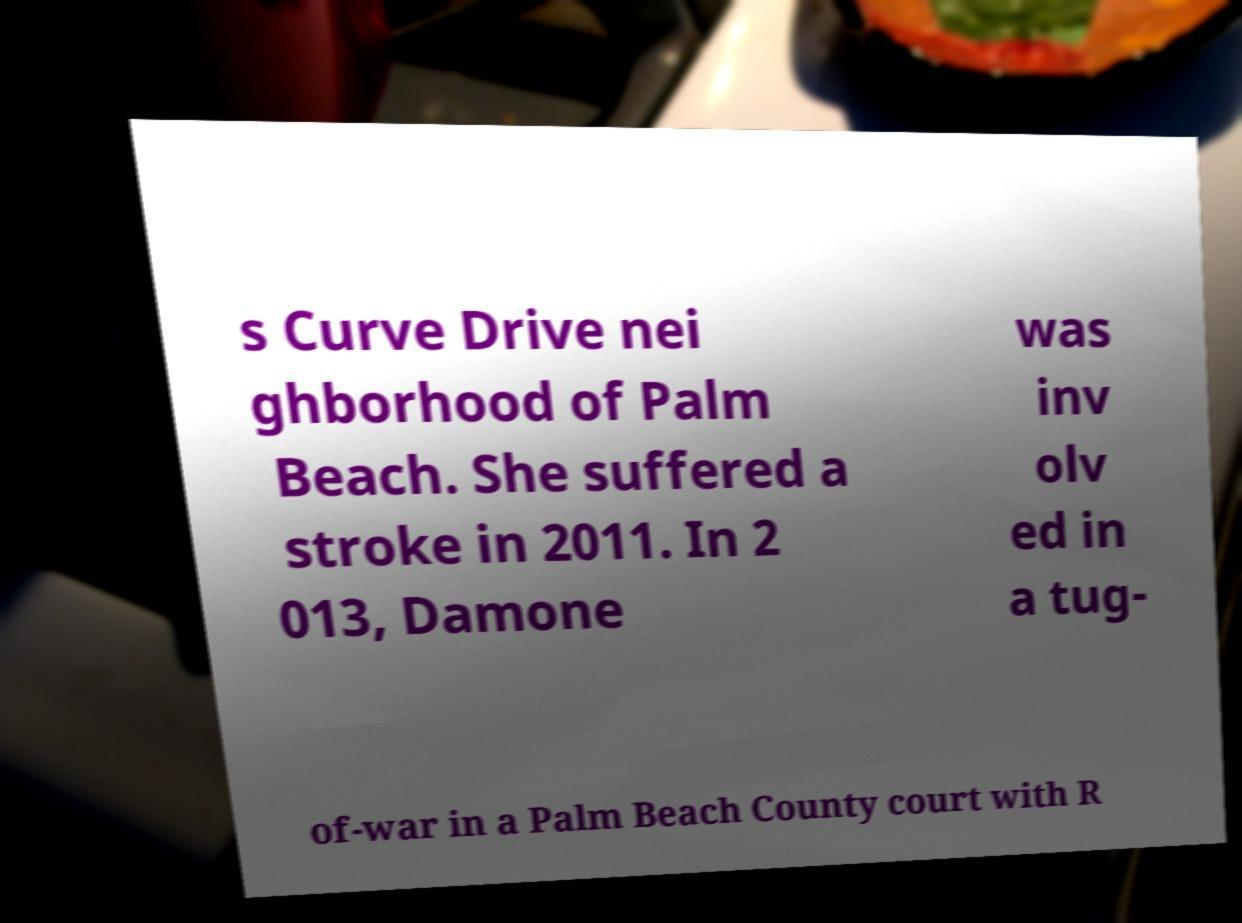I need the written content from this picture converted into text. Can you do that? s Curve Drive nei ghborhood of Palm Beach. She suffered a stroke in 2011. In 2 013, Damone was inv olv ed in a tug- of-war in a Palm Beach County court with R 